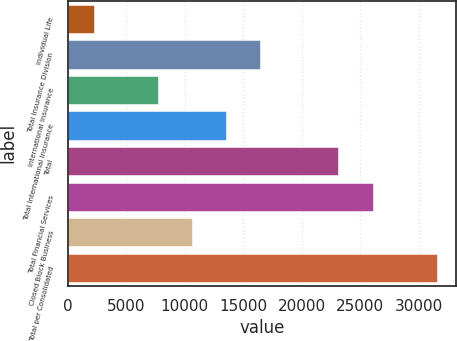Convert chart. <chart><loc_0><loc_0><loc_500><loc_500><bar_chart><fcel>Individual Life<fcel>Total Insurance Division<fcel>International Insurance<fcel>Total International Insurance<fcel>Total<fcel>Total Financial Services<fcel>Closed Block Business<fcel>Total per Consolidated<nl><fcel>2262<fcel>16472.1<fcel>7671<fcel>13538.4<fcel>23128<fcel>26061.7<fcel>10604.7<fcel>31599<nl></chart> 